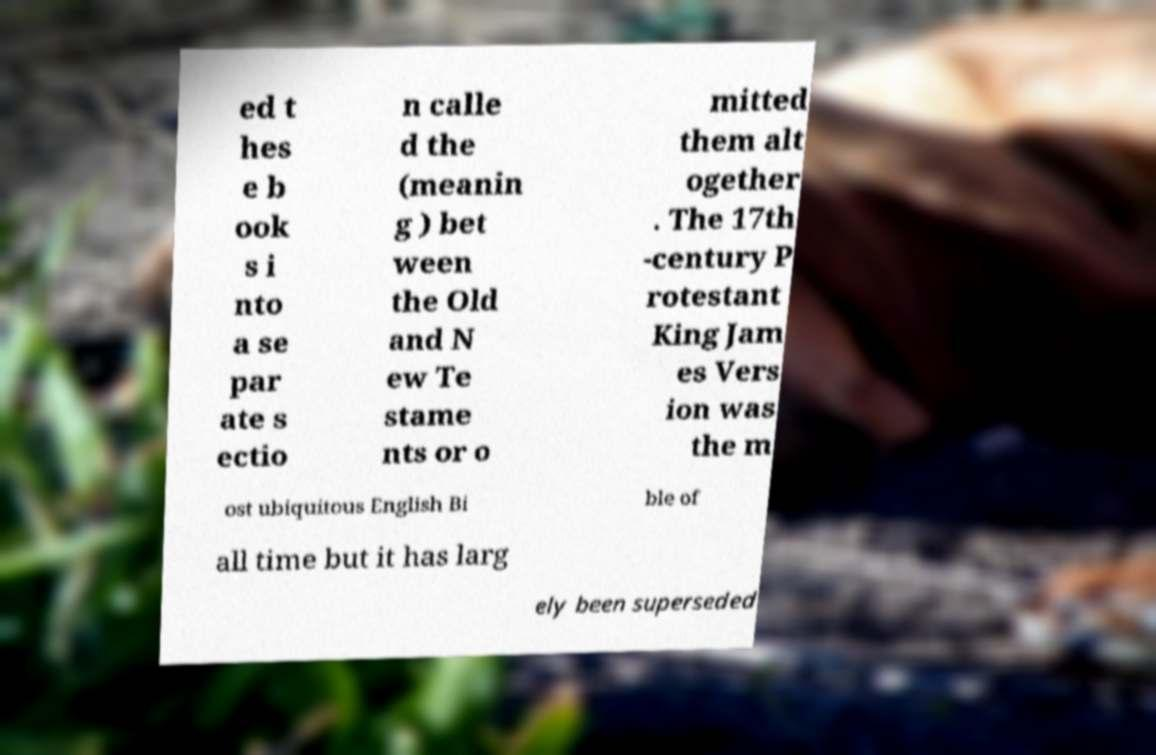Can you accurately transcribe the text from the provided image for me? ed t hes e b ook s i nto a se par ate s ectio n calle d the (meanin g ) bet ween the Old and N ew Te stame nts or o mitted them alt ogether . The 17th -century P rotestant King Jam es Vers ion was the m ost ubiquitous English Bi ble of all time but it has larg ely been superseded 